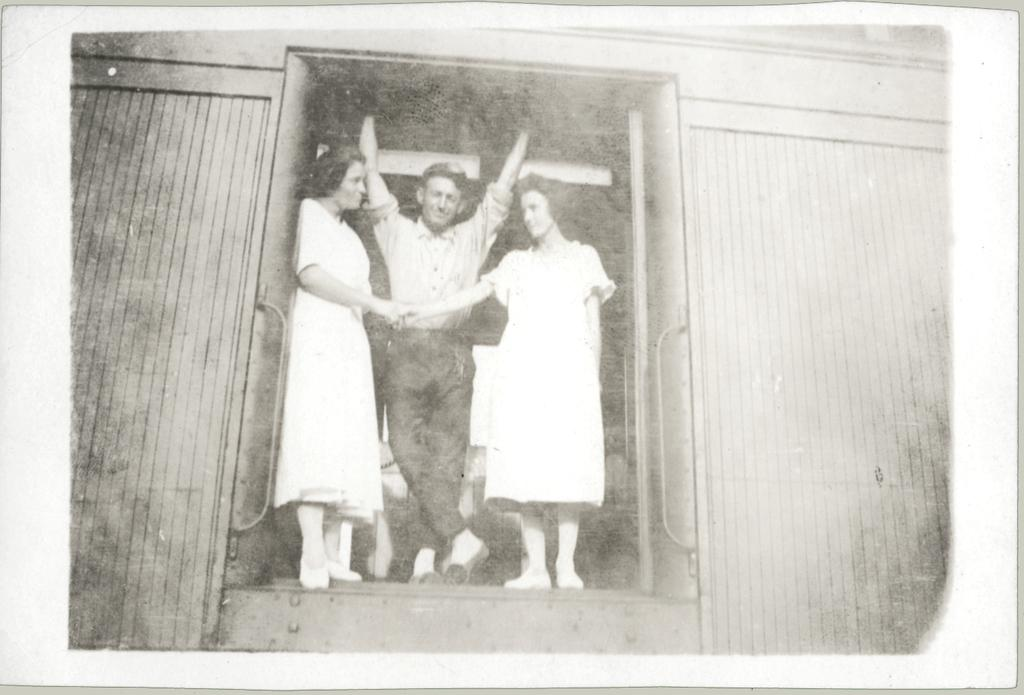What is the color scheme of the image? The image is black and white. Who is the main subject in the image? There is a man standing in the middle of the image. Are there any other people in the image? Yes, there are two women beside the man in the image. Where does the scene take place? The scene takes place within a train wagon. How many divisions can be seen in the image? There is no mention of divisions in the image; it features a man and two women standing in a train wagon. Is there a boy present in the image? No, there is no boy present in the image; it features a man and two women. 